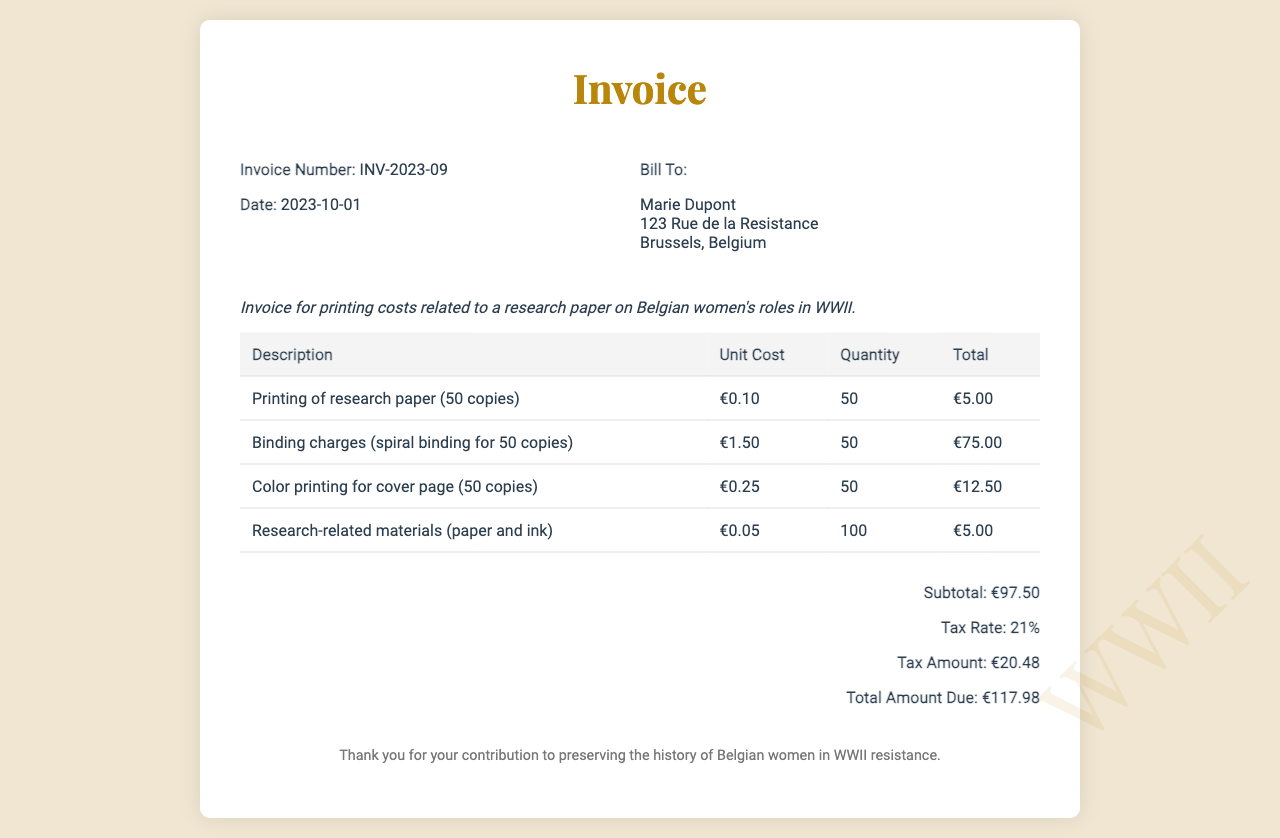What is the invoice number? The invoice number is provided in the invoice details section.
Answer: INV-2023-09 What is the date of the invoice? The date is specified in the invoice details section as the date it was issued.
Answer: 2023-10-01 Who is the bill to? The "Bill To" section includes the name and address of the person being billed.
Answer: Marie Dupont What is the subtotal amount? The subtotal is listed under the total section and represents the sum of service costs before tax.
Answer: €97.50 What is the tax rate? The tax rate is mentioned in the total section of the invoice.
Answer: 21% How many copies of the research paper were printed? The quantity of copies printed is specified in the description of the first item.
Answer: 50 What is the total amount due? The total amount due is stated at the end of the total section, including tax.
Answer: €117.98 What is the binding charge per copy? The unit cost for binding is given for the spiral binding service.
Answer: €1.50 What covers the research-related materials charge? The description of research-related materials indicates what the charge is for.
Answer: Paper and ink 